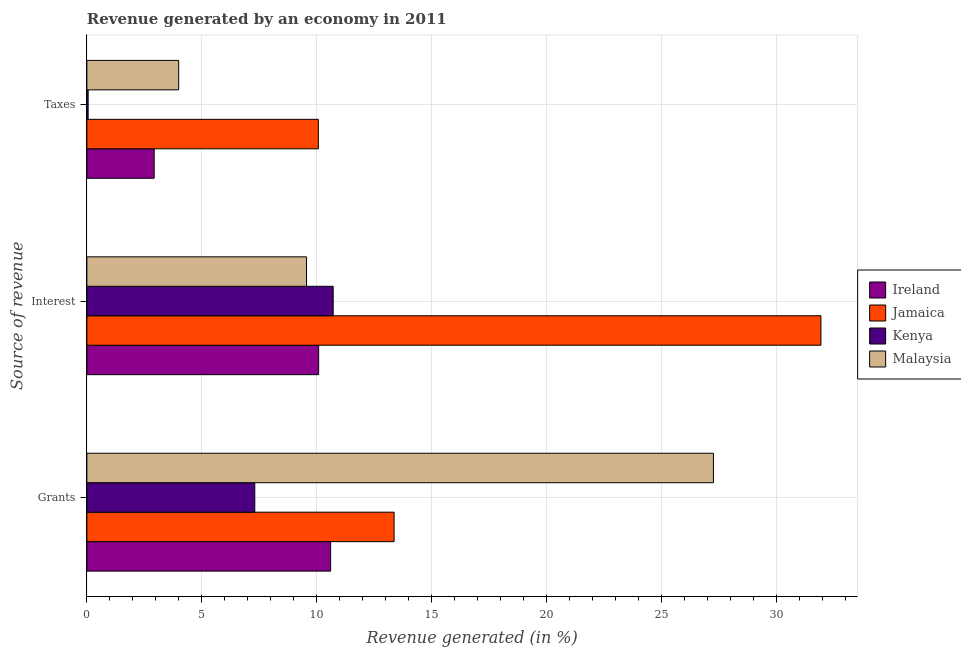How many different coloured bars are there?
Offer a very short reply. 4. How many groups of bars are there?
Give a very brief answer. 3. How many bars are there on the 3rd tick from the top?
Your answer should be compact. 4. What is the label of the 1st group of bars from the top?
Your answer should be compact. Taxes. What is the percentage of revenue generated by taxes in Kenya?
Offer a very short reply. 0.05. Across all countries, what is the maximum percentage of revenue generated by taxes?
Your answer should be very brief. 10.07. Across all countries, what is the minimum percentage of revenue generated by grants?
Provide a short and direct response. 7.3. In which country was the percentage of revenue generated by taxes maximum?
Keep it short and to the point. Jamaica. In which country was the percentage of revenue generated by grants minimum?
Give a very brief answer. Kenya. What is the total percentage of revenue generated by taxes in the graph?
Provide a short and direct response. 17.04. What is the difference between the percentage of revenue generated by grants in Ireland and that in Jamaica?
Your answer should be very brief. -2.76. What is the difference between the percentage of revenue generated by taxes in Kenya and the percentage of revenue generated by interest in Malaysia?
Offer a terse response. -9.5. What is the average percentage of revenue generated by interest per country?
Provide a succinct answer. 15.57. What is the difference between the percentage of revenue generated by taxes and percentage of revenue generated by interest in Jamaica?
Give a very brief answer. -21.86. In how many countries, is the percentage of revenue generated by grants greater than 8 %?
Give a very brief answer. 3. What is the ratio of the percentage of revenue generated by interest in Kenya to that in Malaysia?
Ensure brevity in your answer.  1.12. Is the percentage of revenue generated by taxes in Malaysia less than that in Jamaica?
Provide a succinct answer. Yes. What is the difference between the highest and the second highest percentage of revenue generated by taxes?
Provide a short and direct response. 6.08. What is the difference between the highest and the lowest percentage of revenue generated by interest?
Provide a short and direct response. 22.38. What does the 4th bar from the top in Taxes represents?
Offer a very short reply. Ireland. What does the 1st bar from the bottom in Grants represents?
Ensure brevity in your answer.  Ireland. How many bars are there?
Provide a succinct answer. 12. Are all the bars in the graph horizontal?
Ensure brevity in your answer.  Yes. How many countries are there in the graph?
Ensure brevity in your answer.  4. Are the values on the major ticks of X-axis written in scientific E-notation?
Provide a succinct answer. No. Does the graph contain any zero values?
Your answer should be very brief. No. Does the graph contain grids?
Ensure brevity in your answer.  Yes. Where does the legend appear in the graph?
Provide a succinct answer. Center right. How many legend labels are there?
Provide a short and direct response. 4. How are the legend labels stacked?
Provide a succinct answer. Vertical. What is the title of the graph?
Your answer should be compact. Revenue generated by an economy in 2011. What is the label or title of the X-axis?
Offer a terse response. Revenue generated (in %). What is the label or title of the Y-axis?
Offer a terse response. Source of revenue. What is the Revenue generated (in %) of Ireland in Grants?
Make the answer very short. 10.6. What is the Revenue generated (in %) in Jamaica in Grants?
Your answer should be compact. 13.36. What is the Revenue generated (in %) in Kenya in Grants?
Ensure brevity in your answer.  7.3. What is the Revenue generated (in %) in Malaysia in Grants?
Offer a very short reply. 27.25. What is the Revenue generated (in %) of Ireland in Interest?
Give a very brief answer. 10.08. What is the Revenue generated (in %) of Jamaica in Interest?
Give a very brief answer. 31.93. What is the Revenue generated (in %) in Kenya in Interest?
Your answer should be very brief. 10.71. What is the Revenue generated (in %) in Malaysia in Interest?
Ensure brevity in your answer.  9.55. What is the Revenue generated (in %) of Ireland in Taxes?
Your answer should be very brief. 2.93. What is the Revenue generated (in %) of Jamaica in Taxes?
Provide a succinct answer. 10.07. What is the Revenue generated (in %) of Kenya in Taxes?
Provide a short and direct response. 0.05. What is the Revenue generated (in %) in Malaysia in Taxes?
Provide a short and direct response. 3.99. Across all Source of revenue, what is the maximum Revenue generated (in %) of Ireland?
Make the answer very short. 10.6. Across all Source of revenue, what is the maximum Revenue generated (in %) of Jamaica?
Keep it short and to the point. 31.93. Across all Source of revenue, what is the maximum Revenue generated (in %) in Kenya?
Your answer should be compact. 10.71. Across all Source of revenue, what is the maximum Revenue generated (in %) of Malaysia?
Offer a terse response. 27.25. Across all Source of revenue, what is the minimum Revenue generated (in %) of Ireland?
Keep it short and to the point. 2.93. Across all Source of revenue, what is the minimum Revenue generated (in %) of Jamaica?
Provide a succinct answer. 10.07. Across all Source of revenue, what is the minimum Revenue generated (in %) of Kenya?
Make the answer very short. 0.05. Across all Source of revenue, what is the minimum Revenue generated (in %) in Malaysia?
Your answer should be very brief. 3.99. What is the total Revenue generated (in %) in Ireland in the graph?
Provide a short and direct response. 23.61. What is the total Revenue generated (in %) of Jamaica in the graph?
Make the answer very short. 55.36. What is the total Revenue generated (in %) in Kenya in the graph?
Provide a short and direct response. 18.07. What is the total Revenue generated (in %) in Malaysia in the graph?
Ensure brevity in your answer.  40.8. What is the difference between the Revenue generated (in %) in Ireland in Grants and that in Interest?
Your answer should be compact. 0.52. What is the difference between the Revenue generated (in %) in Jamaica in Grants and that in Interest?
Your answer should be very brief. -18.57. What is the difference between the Revenue generated (in %) of Kenya in Grants and that in Interest?
Keep it short and to the point. -3.41. What is the difference between the Revenue generated (in %) in Malaysia in Grants and that in Interest?
Ensure brevity in your answer.  17.7. What is the difference between the Revenue generated (in %) of Ireland in Grants and that in Taxes?
Ensure brevity in your answer.  7.68. What is the difference between the Revenue generated (in %) in Jamaica in Grants and that in Taxes?
Provide a succinct answer. 3.29. What is the difference between the Revenue generated (in %) of Kenya in Grants and that in Taxes?
Your answer should be compact. 7.25. What is the difference between the Revenue generated (in %) of Malaysia in Grants and that in Taxes?
Provide a short and direct response. 23.26. What is the difference between the Revenue generated (in %) of Ireland in Interest and that in Taxes?
Offer a very short reply. 7.16. What is the difference between the Revenue generated (in %) in Jamaica in Interest and that in Taxes?
Give a very brief answer. 21.86. What is the difference between the Revenue generated (in %) in Kenya in Interest and that in Taxes?
Offer a very short reply. 10.66. What is the difference between the Revenue generated (in %) in Malaysia in Interest and that in Taxes?
Your answer should be compact. 5.56. What is the difference between the Revenue generated (in %) of Ireland in Grants and the Revenue generated (in %) of Jamaica in Interest?
Keep it short and to the point. -21.33. What is the difference between the Revenue generated (in %) of Ireland in Grants and the Revenue generated (in %) of Kenya in Interest?
Keep it short and to the point. -0.11. What is the difference between the Revenue generated (in %) of Ireland in Grants and the Revenue generated (in %) of Malaysia in Interest?
Provide a short and direct response. 1.05. What is the difference between the Revenue generated (in %) of Jamaica in Grants and the Revenue generated (in %) of Kenya in Interest?
Keep it short and to the point. 2.65. What is the difference between the Revenue generated (in %) in Jamaica in Grants and the Revenue generated (in %) in Malaysia in Interest?
Your answer should be very brief. 3.81. What is the difference between the Revenue generated (in %) in Kenya in Grants and the Revenue generated (in %) in Malaysia in Interest?
Your answer should be very brief. -2.25. What is the difference between the Revenue generated (in %) of Ireland in Grants and the Revenue generated (in %) of Jamaica in Taxes?
Make the answer very short. 0.53. What is the difference between the Revenue generated (in %) in Ireland in Grants and the Revenue generated (in %) in Kenya in Taxes?
Offer a very short reply. 10.55. What is the difference between the Revenue generated (in %) in Ireland in Grants and the Revenue generated (in %) in Malaysia in Taxes?
Provide a succinct answer. 6.61. What is the difference between the Revenue generated (in %) in Jamaica in Grants and the Revenue generated (in %) in Kenya in Taxes?
Offer a terse response. 13.31. What is the difference between the Revenue generated (in %) in Jamaica in Grants and the Revenue generated (in %) in Malaysia in Taxes?
Make the answer very short. 9.37. What is the difference between the Revenue generated (in %) in Kenya in Grants and the Revenue generated (in %) in Malaysia in Taxes?
Your answer should be compact. 3.31. What is the difference between the Revenue generated (in %) in Ireland in Interest and the Revenue generated (in %) in Jamaica in Taxes?
Give a very brief answer. 0.01. What is the difference between the Revenue generated (in %) in Ireland in Interest and the Revenue generated (in %) in Kenya in Taxes?
Offer a very short reply. 10.03. What is the difference between the Revenue generated (in %) in Ireland in Interest and the Revenue generated (in %) in Malaysia in Taxes?
Provide a short and direct response. 6.09. What is the difference between the Revenue generated (in %) of Jamaica in Interest and the Revenue generated (in %) of Kenya in Taxes?
Your response must be concise. 31.87. What is the difference between the Revenue generated (in %) in Jamaica in Interest and the Revenue generated (in %) in Malaysia in Taxes?
Provide a succinct answer. 27.94. What is the difference between the Revenue generated (in %) in Kenya in Interest and the Revenue generated (in %) in Malaysia in Taxes?
Provide a succinct answer. 6.72. What is the average Revenue generated (in %) of Ireland per Source of revenue?
Keep it short and to the point. 7.87. What is the average Revenue generated (in %) in Jamaica per Source of revenue?
Your answer should be very brief. 18.45. What is the average Revenue generated (in %) in Kenya per Source of revenue?
Your answer should be compact. 6.02. What is the average Revenue generated (in %) in Malaysia per Source of revenue?
Keep it short and to the point. 13.6. What is the difference between the Revenue generated (in %) of Ireland and Revenue generated (in %) of Jamaica in Grants?
Your answer should be compact. -2.76. What is the difference between the Revenue generated (in %) in Ireland and Revenue generated (in %) in Kenya in Grants?
Your answer should be very brief. 3.3. What is the difference between the Revenue generated (in %) in Ireland and Revenue generated (in %) in Malaysia in Grants?
Offer a terse response. -16.65. What is the difference between the Revenue generated (in %) of Jamaica and Revenue generated (in %) of Kenya in Grants?
Make the answer very short. 6.06. What is the difference between the Revenue generated (in %) of Jamaica and Revenue generated (in %) of Malaysia in Grants?
Your answer should be very brief. -13.89. What is the difference between the Revenue generated (in %) of Kenya and Revenue generated (in %) of Malaysia in Grants?
Keep it short and to the point. -19.95. What is the difference between the Revenue generated (in %) in Ireland and Revenue generated (in %) in Jamaica in Interest?
Provide a short and direct response. -21.85. What is the difference between the Revenue generated (in %) in Ireland and Revenue generated (in %) in Kenya in Interest?
Your response must be concise. -0.63. What is the difference between the Revenue generated (in %) of Ireland and Revenue generated (in %) of Malaysia in Interest?
Make the answer very short. 0.53. What is the difference between the Revenue generated (in %) in Jamaica and Revenue generated (in %) in Kenya in Interest?
Keep it short and to the point. 21.22. What is the difference between the Revenue generated (in %) of Jamaica and Revenue generated (in %) of Malaysia in Interest?
Ensure brevity in your answer.  22.38. What is the difference between the Revenue generated (in %) of Kenya and Revenue generated (in %) of Malaysia in Interest?
Provide a short and direct response. 1.16. What is the difference between the Revenue generated (in %) of Ireland and Revenue generated (in %) of Jamaica in Taxes?
Give a very brief answer. -7.14. What is the difference between the Revenue generated (in %) of Ireland and Revenue generated (in %) of Kenya in Taxes?
Make the answer very short. 2.87. What is the difference between the Revenue generated (in %) of Ireland and Revenue generated (in %) of Malaysia in Taxes?
Provide a succinct answer. -1.07. What is the difference between the Revenue generated (in %) of Jamaica and Revenue generated (in %) of Kenya in Taxes?
Give a very brief answer. 10.01. What is the difference between the Revenue generated (in %) of Jamaica and Revenue generated (in %) of Malaysia in Taxes?
Give a very brief answer. 6.08. What is the difference between the Revenue generated (in %) of Kenya and Revenue generated (in %) of Malaysia in Taxes?
Your answer should be very brief. -3.94. What is the ratio of the Revenue generated (in %) in Ireland in Grants to that in Interest?
Offer a very short reply. 1.05. What is the ratio of the Revenue generated (in %) in Jamaica in Grants to that in Interest?
Offer a very short reply. 0.42. What is the ratio of the Revenue generated (in %) of Kenya in Grants to that in Interest?
Make the answer very short. 0.68. What is the ratio of the Revenue generated (in %) of Malaysia in Grants to that in Interest?
Keep it short and to the point. 2.85. What is the ratio of the Revenue generated (in %) in Ireland in Grants to that in Taxes?
Your response must be concise. 3.62. What is the ratio of the Revenue generated (in %) in Jamaica in Grants to that in Taxes?
Your answer should be very brief. 1.33. What is the ratio of the Revenue generated (in %) of Kenya in Grants to that in Taxes?
Offer a very short reply. 132.96. What is the ratio of the Revenue generated (in %) of Malaysia in Grants to that in Taxes?
Provide a succinct answer. 6.83. What is the ratio of the Revenue generated (in %) of Ireland in Interest to that in Taxes?
Provide a short and direct response. 3.44. What is the ratio of the Revenue generated (in %) of Jamaica in Interest to that in Taxes?
Make the answer very short. 3.17. What is the ratio of the Revenue generated (in %) of Kenya in Interest to that in Taxes?
Offer a very short reply. 195.05. What is the ratio of the Revenue generated (in %) in Malaysia in Interest to that in Taxes?
Provide a succinct answer. 2.39. What is the difference between the highest and the second highest Revenue generated (in %) of Ireland?
Provide a succinct answer. 0.52. What is the difference between the highest and the second highest Revenue generated (in %) of Jamaica?
Your answer should be very brief. 18.57. What is the difference between the highest and the second highest Revenue generated (in %) of Kenya?
Ensure brevity in your answer.  3.41. What is the difference between the highest and the second highest Revenue generated (in %) of Malaysia?
Offer a terse response. 17.7. What is the difference between the highest and the lowest Revenue generated (in %) in Ireland?
Your response must be concise. 7.68. What is the difference between the highest and the lowest Revenue generated (in %) in Jamaica?
Your response must be concise. 21.86. What is the difference between the highest and the lowest Revenue generated (in %) in Kenya?
Your answer should be very brief. 10.66. What is the difference between the highest and the lowest Revenue generated (in %) in Malaysia?
Your answer should be compact. 23.26. 